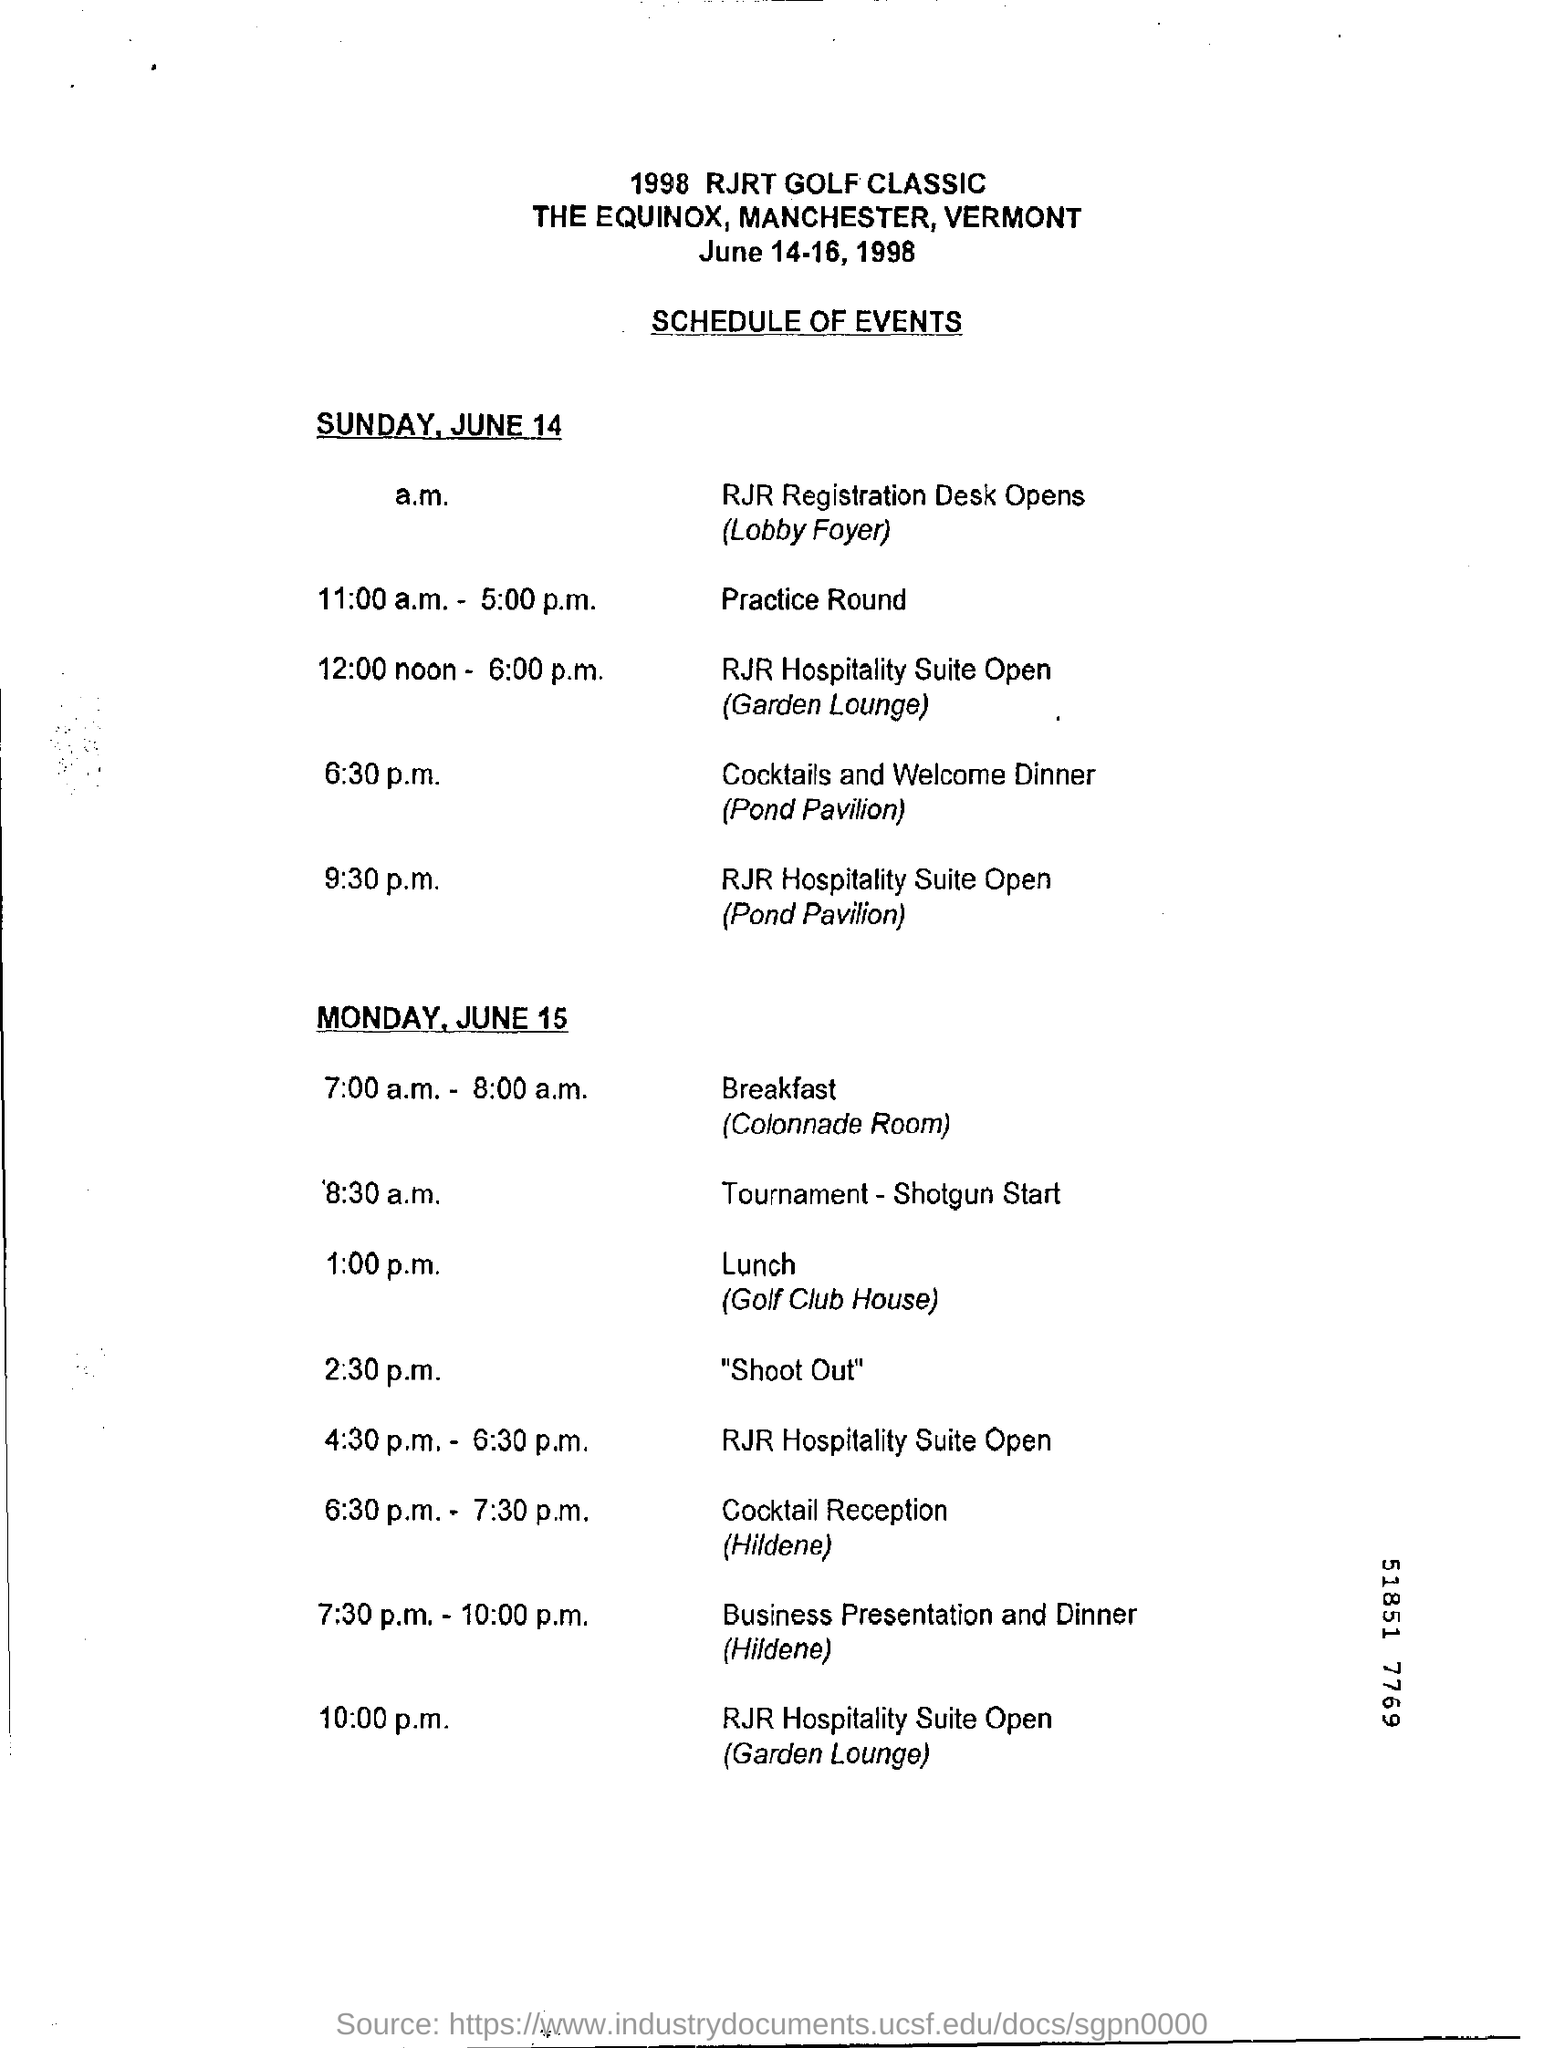Highlight a few significant elements in this photo. At 6:30 p.m. on Sunday, June 14, a cocktails and welcome dinner is scheduled to take place. On Monday, June 15, there will be a business presentation and dinner scheduled from 7:30 p.m. to 10:00 p.m. 